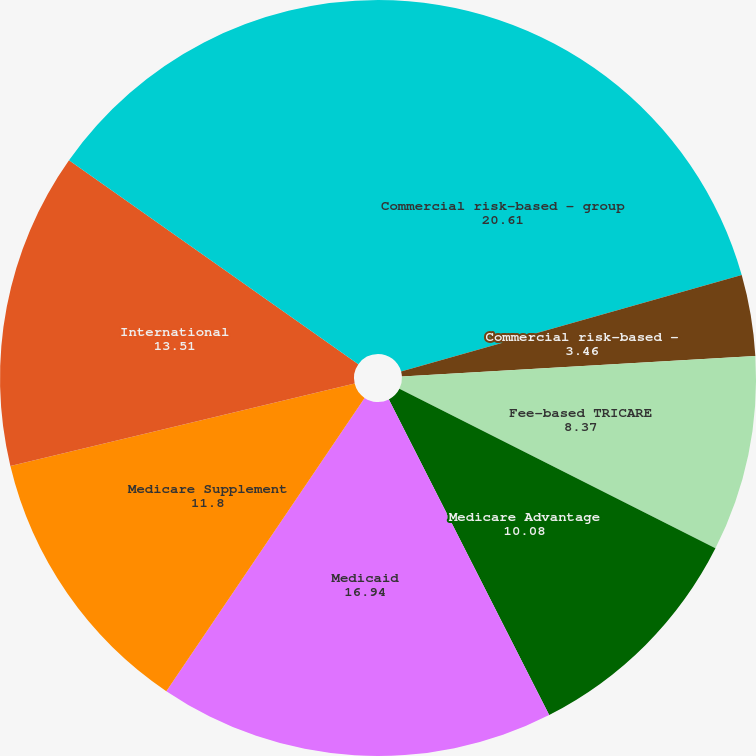Convert chart to OTSL. <chart><loc_0><loc_0><loc_500><loc_500><pie_chart><fcel>Commercial risk-based - group<fcel>Commercial risk-based -<fcel>Fee-based TRICARE<fcel>Medicare Advantage<fcel>Medicaid<fcel>Medicare Supplement<fcel>International<fcel>Medicare Part D stand-alone<nl><fcel>20.61%<fcel>3.46%<fcel>8.37%<fcel>10.08%<fcel>16.94%<fcel>11.8%<fcel>13.51%<fcel>15.23%<nl></chart> 